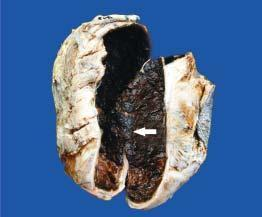what shows thick wall coated internally by brownish, tan and necrotic material which is organised blood clot?
Answer the question using a single word or phrase. Sectioned surface of the sac 